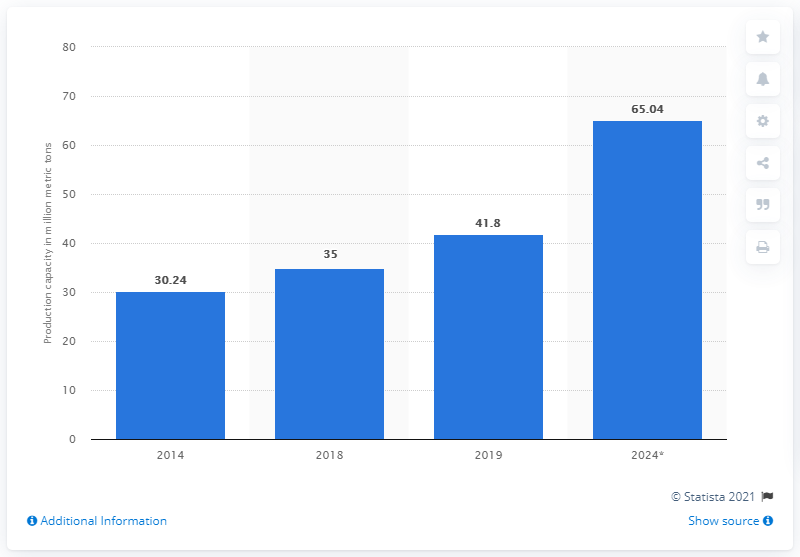List a handful of essential elements in this visual. The global production capacity of ethylene glycol is expected to reach 65.04 million metric tons in 2024, according to industry experts and market reports. This represents a significant increase from the current capacity and highlights the ongoing growth in demand for this important chemical in various industries. The market for ethylene glycol is highly competitive, with several major players operating worldwide, each with their own production capacities and strategies. As the demand for ethylene glycol continues to rise, it will be interesting to see how the market adjusts and evolves in the coming years. The world's production capacity of ethylene glycol in 2019 was 41.8 million metric tons. 